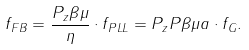Convert formula to latex. <formula><loc_0><loc_0><loc_500><loc_500>f _ { F B } = \frac { P _ { z } \beta \mu } { \eta } \cdot f _ { P L L } = P _ { z } P \beta \mu a \cdot f _ { G } .</formula> 